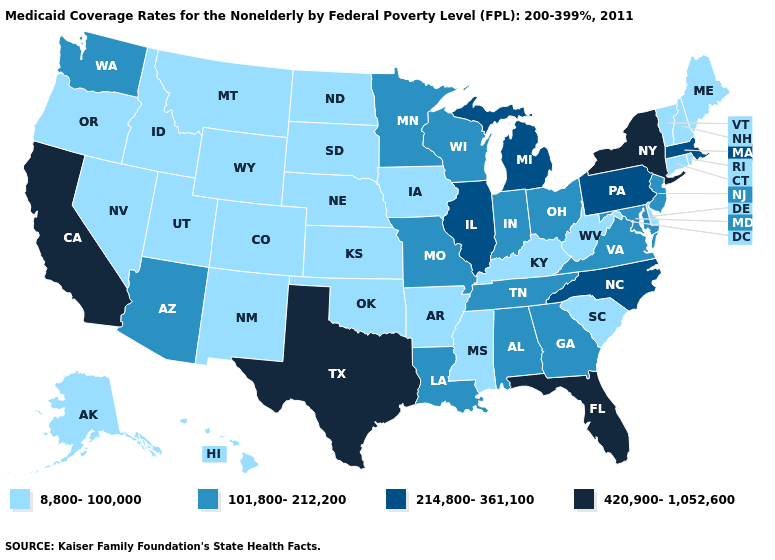How many symbols are there in the legend?
Write a very short answer. 4. What is the value of California?
Concise answer only. 420,900-1,052,600. What is the lowest value in the USA?
Answer briefly. 8,800-100,000. What is the lowest value in states that border Massachusetts?
Concise answer only. 8,800-100,000. Among the states that border Iowa , does Nebraska have the lowest value?
Concise answer only. Yes. What is the value of Rhode Island?
Write a very short answer. 8,800-100,000. Name the states that have a value in the range 420,900-1,052,600?
Be succinct. California, Florida, New York, Texas. Does North Dakota have the lowest value in the MidWest?
Short answer required. Yes. What is the value of Rhode Island?
Quick response, please. 8,800-100,000. What is the value of Montana?
Quick response, please. 8,800-100,000. What is the value of Arizona?
Quick response, please. 101,800-212,200. Name the states that have a value in the range 214,800-361,100?
Write a very short answer. Illinois, Massachusetts, Michigan, North Carolina, Pennsylvania. Does the first symbol in the legend represent the smallest category?
Write a very short answer. Yes. What is the value of Virginia?
Concise answer only. 101,800-212,200. What is the value of Texas?
Short answer required. 420,900-1,052,600. 